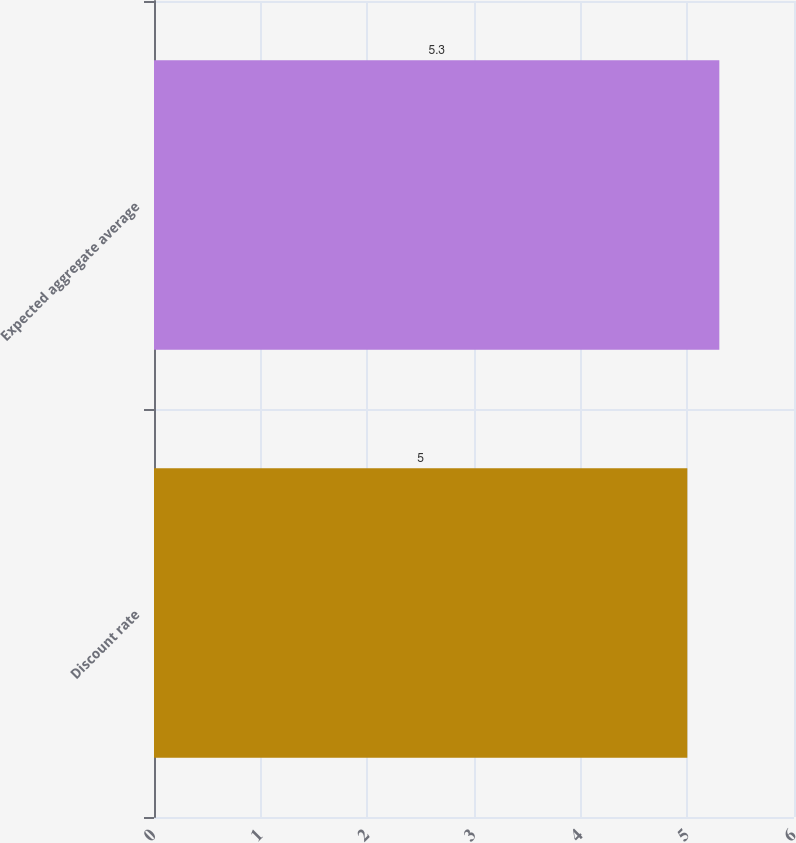<chart> <loc_0><loc_0><loc_500><loc_500><bar_chart><fcel>Discount rate<fcel>Expected aggregate average<nl><fcel>5<fcel>5.3<nl></chart> 